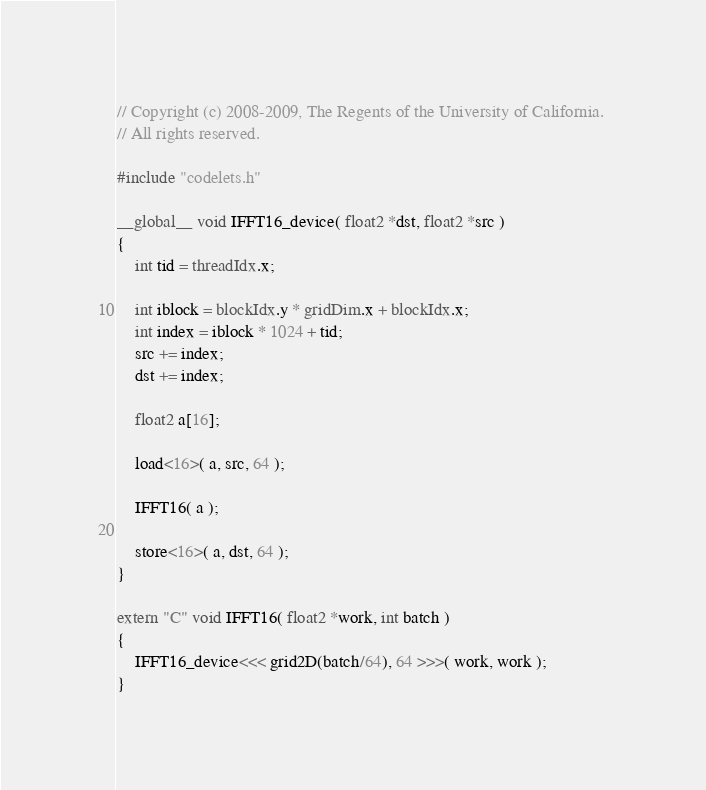<code> <loc_0><loc_0><loc_500><loc_500><_Cuda_>// Copyright (c) 2008-2009, The Regents of the University of California. 
// All rights reserved.

#include "codelets.h"

__global__ void IFFT16_device( float2 *dst, float2 *src )
{	
    int tid = threadIdx.x;
    
    int iblock = blockIdx.y * gridDim.x + blockIdx.x;
    int index = iblock * 1024 + tid;
    src += index;
    dst += index;
    
    float2 a[16];
    
    load<16>( a, src, 64 );

    IFFT16( a );

    store<16>( a, dst, 64 );
}	
    
extern "C" void IFFT16( float2 *work, int batch )
{	
    IFFT16_device<<< grid2D(batch/64), 64 >>>( work, work );
}	
</code> 